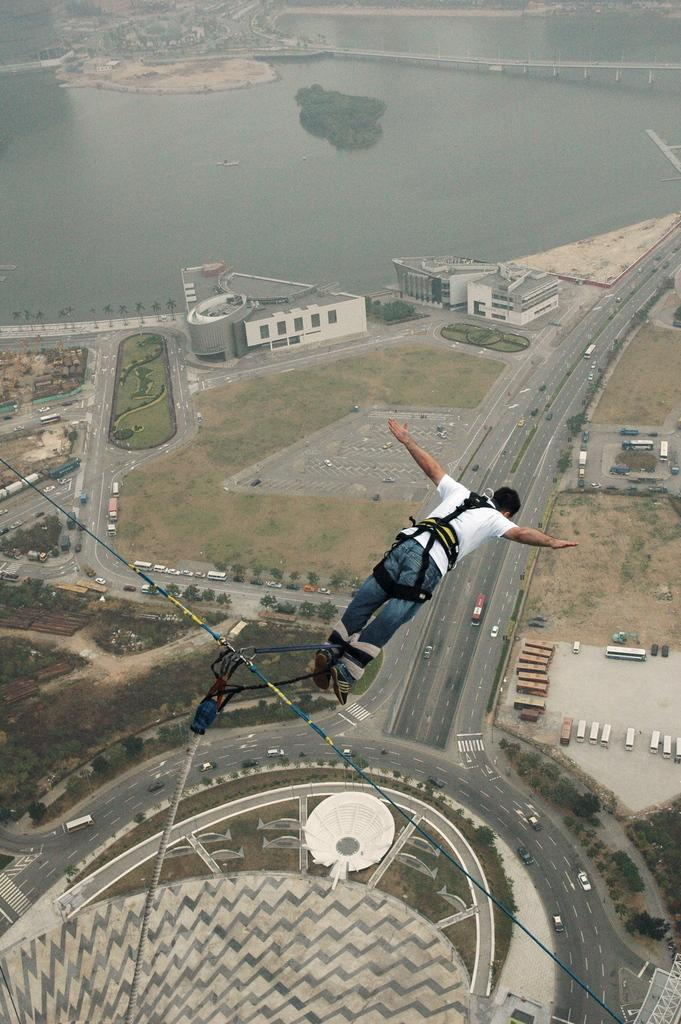What is the main subject of the image? There is a man in the image. What is the man doing in the image? The man is jumping. How is the man connected to other objects in the image? The man is tied with cables. What can be seen on the road in the image? There are vehicles on the road in the image. What is visible in the background of the image? There are buildings, trees, and water visible in the background of the image. Where is the cellar located in the image? There is no cellar present in the image. What type of beetle can be seen crawling on the man's shoulder in the image? There is no beetle present in the image. 